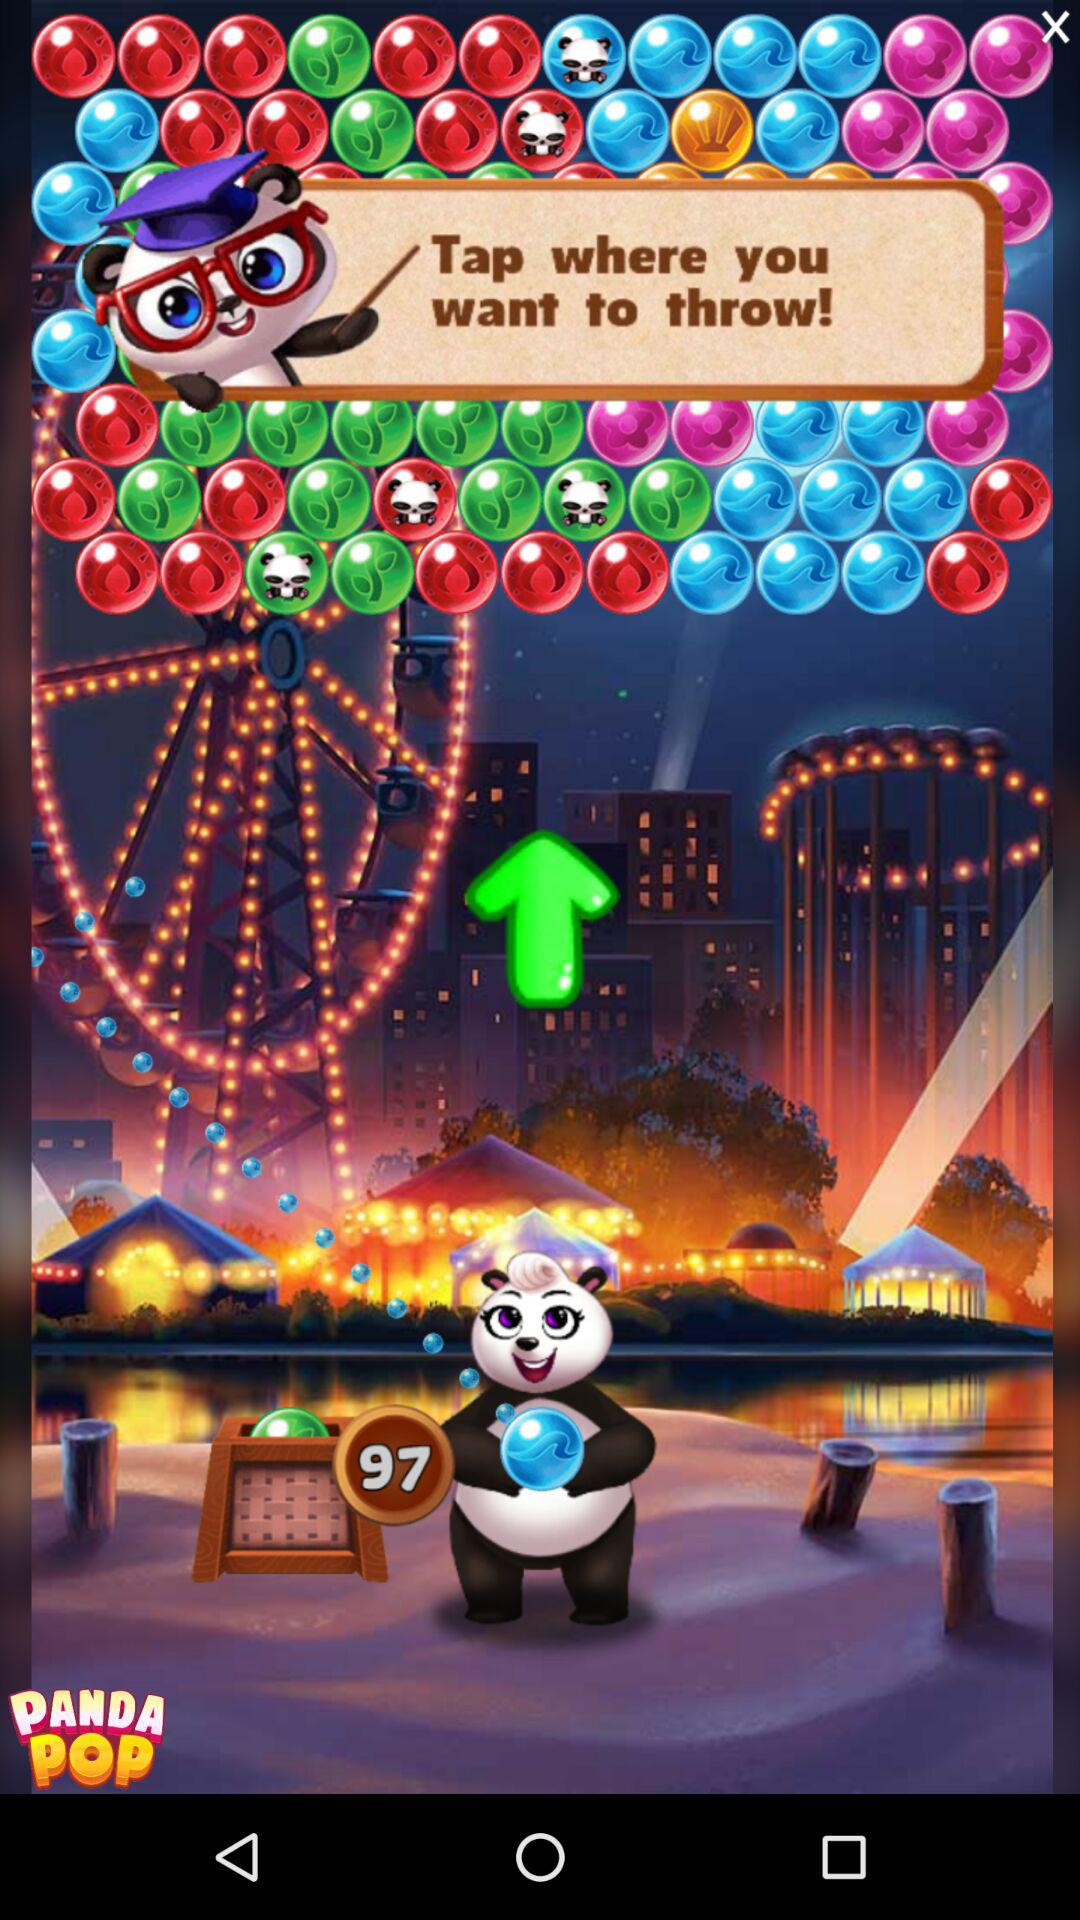What number is shown on the screen? The number is 97. 